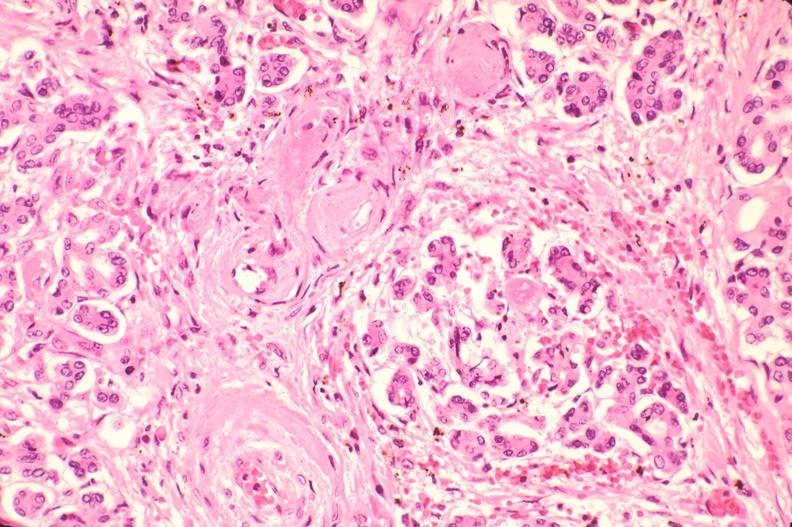does this image show pancreas, microthrombi, thrombotic thrombocytopenic purpura?
Answer the question using a single word or phrase. Yes 